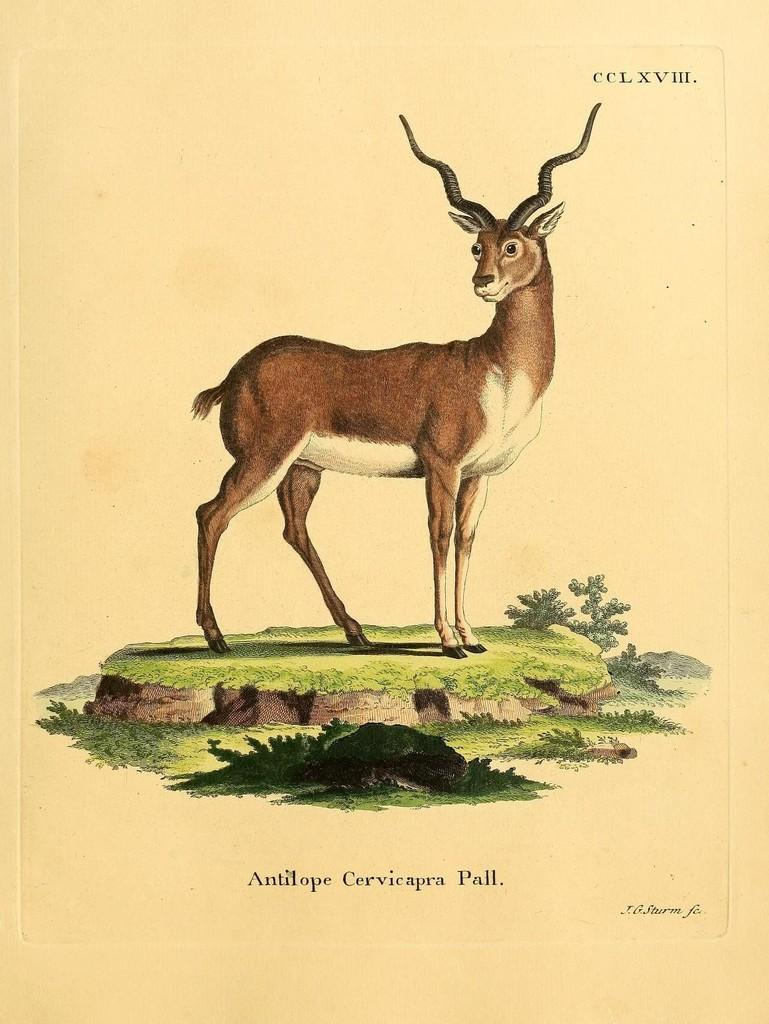What type of living creature is shown in the image? There is an animal depicted in the image. What other elements can be seen in the image besides the animal? There are plants and text in the image. What type of thread is being used to give the animal a haircut in the image? There is no thread or haircut present in the image; it features an animal, plants, and text. 